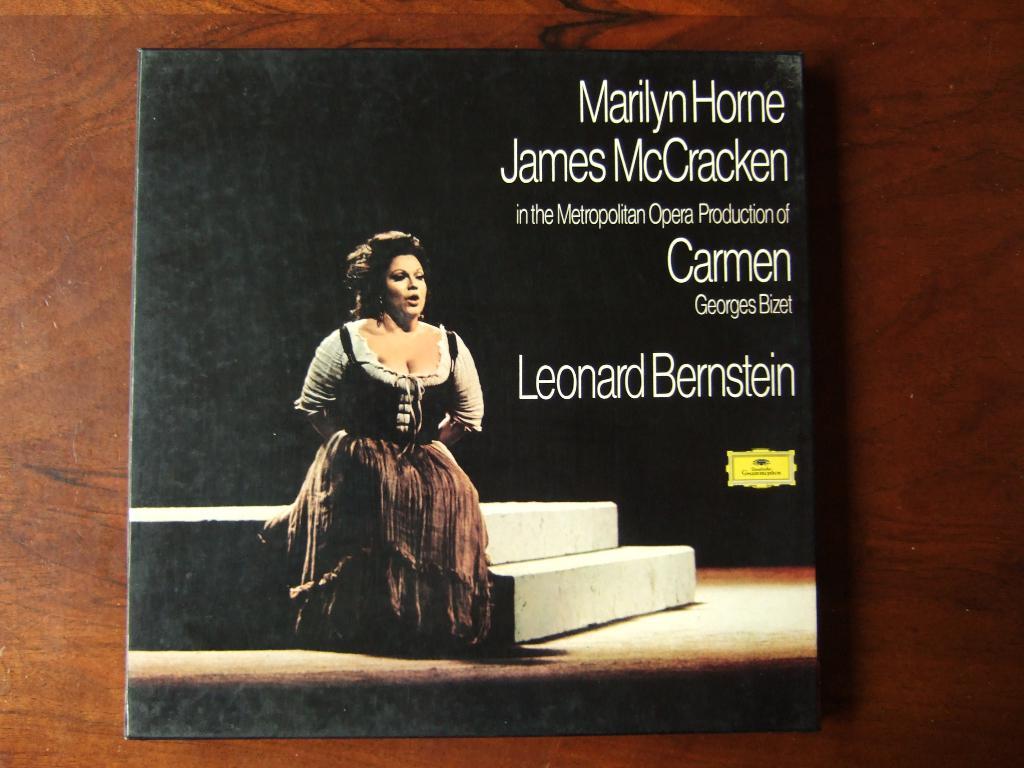What production is marilyn horne a part of?
Provide a succinct answer. Carmen. Who conducted this opera?
Provide a succinct answer. Leonard bernstein. 